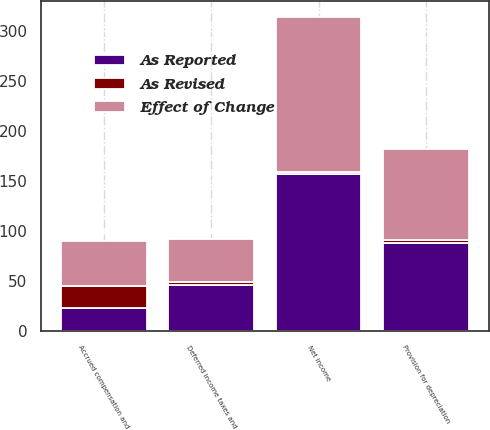<chart> <loc_0><loc_0><loc_500><loc_500><stacked_bar_chart><ecel><fcel>Net income<fcel>Provision for depreciation<fcel>Deferred income taxes and<fcel>Accrued compensation and<nl><fcel>As Reported<fcel>157<fcel>88<fcel>46<fcel>23<nl><fcel>As Revised<fcel>2<fcel>3<fcel>3<fcel>22<nl><fcel>Effect of Change<fcel>155<fcel>91<fcel>43<fcel>45<nl></chart> 